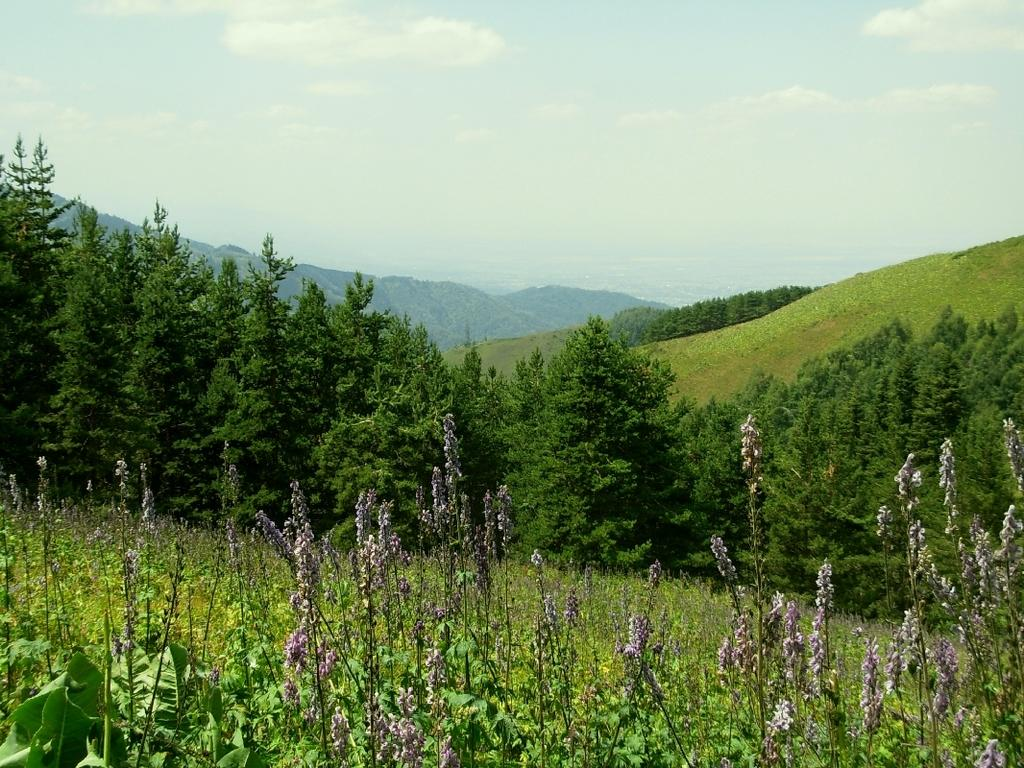What type of vegetation can be seen in the image? There are trees with branches and leaves in the image. What type of landscape feature is visible in the image? There are hills visible in the image. What type of plants are present in the image? There are plants with flowers in the image. What is visible in the sky in the image? Clouds are present in the sky in the image. What type of beef is being served at the picnic in the image? There is no picnic or beef present in the image; it features trees, hills, plants with flowers, and clouds in the sky. 